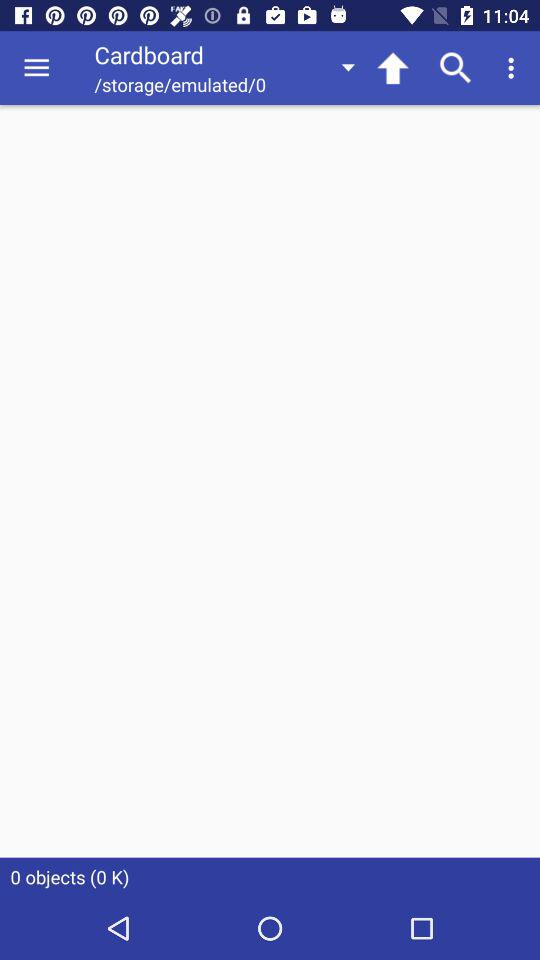How many objects are there? There are 0 objects. 